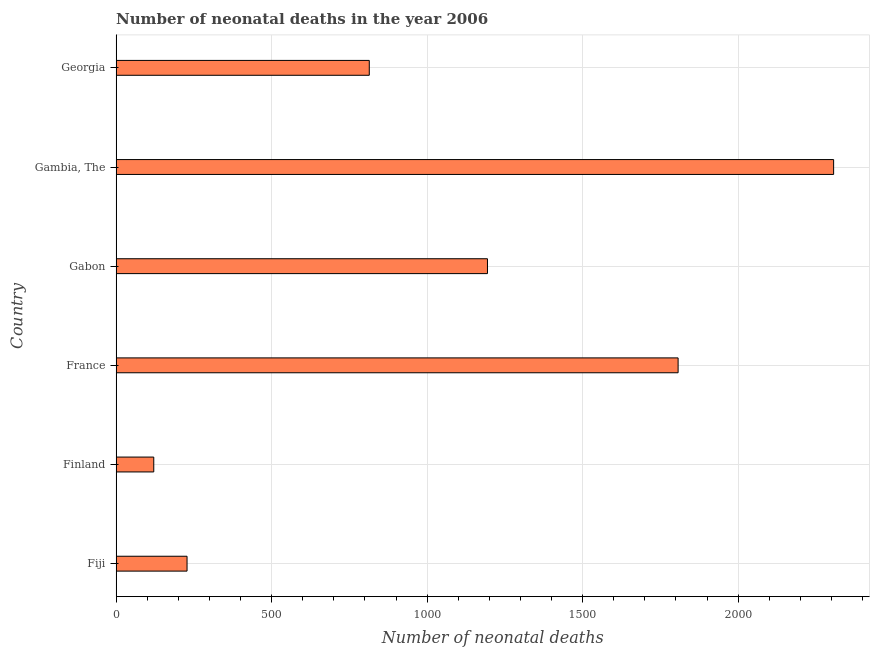What is the title of the graph?
Keep it short and to the point. Number of neonatal deaths in the year 2006. What is the label or title of the X-axis?
Your answer should be compact. Number of neonatal deaths. What is the label or title of the Y-axis?
Your answer should be compact. Country. What is the number of neonatal deaths in Gambia, The?
Provide a short and direct response. 2307. Across all countries, what is the maximum number of neonatal deaths?
Provide a short and direct response. 2307. Across all countries, what is the minimum number of neonatal deaths?
Offer a very short reply. 121. In which country was the number of neonatal deaths maximum?
Make the answer very short. Gambia, The. In which country was the number of neonatal deaths minimum?
Offer a very short reply. Finland. What is the sum of the number of neonatal deaths?
Make the answer very short. 6471. What is the difference between the number of neonatal deaths in France and Georgia?
Your answer should be very brief. 993. What is the average number of neonatal deaths per country?
Give a very brief answer. 1078. What is the median number of neonatal deaths?
Your answer should be very brief. 1004. In how many countries, is the number of neonatal deaths greater than 400 ?
Your answer should be compact. 4. What is the ratio of the number of neonatal deaths in France to that in Gambia, The?
Your response must be concise. 0.78. Is the number of neonatal deaths in Gabon less than that in Georgia?
Keep it short and to the point. No. Is the difference between the number of neonatal deaths in France and Georgia greater than the difference between any two countries?
Your response must be concise. No. What is the difference between the highest and the lowest number of neonatal deaths?
Your response must be concise. 2186. How many bars are there?
Ensure brevity in your answer.  6. How many countries are there in the graph?
Give a very brief answer. 6. Are the values on the major ticks of X-axis written in scientific E-notation?
Provide a succinct answer. No. What is the Number of neonatal deaths in Fiji?
Offer a terse response. 228. What is the Number of neonatal deaths of Finland?
Provide a succinct answer. 121. What is the Number of neonatal deaths in France?
Provide a succinct answer. 1807. What is the Number of neonatal deaths of Gabon?
Make the answer very short. 1194. What is the Number of neonatal deaths of Gambia, The?
Keep it short and to the point. 2307. What is the Number of neonatal deaths in Georgia?
Provide a succinct answer. 814. What is the difference between the Number of neonatal deaths in Fiji and Finland?
Ensure brevity in your answer.  107. What is the difference between the Number of neonatal deaths in Fiji and France?
Your answer should be very brief. -1579. What is the difference between the Number of neonatal deaths in Fiji and Gabon?
Your answer should be very brief. -966. What is the difference between the Number of neonatal deaths in Fiji and Gambia, The?
Ensure brevity in your answer.  -2079. What is the difference between the Number of neonatal deaths in Fiji and Georgia?
Offer a very short reply. -586. What is the difference between the Number of neonatal deaths in Finland and France?
Offer a very short reply. -1686. What is the difference between the Number of neonatal deaths in Finland and Gabon?
Your answer should be very brief. -1073. What is the difference between the Number of neonatal deaths in Finland and Gambia, The?
Offer a very short reply. -2186. What is the difference between the Number of neonatal deaths in Finland and Georgia?
Ensure brevity in your answer.  -693. What is the difference between the Number of neonatal deaths in France and Gabon?
Offer a very short reply. 613. What is the difference between the Number of neonatal deaths in France and Gambia, The?
Provide a succinct answer. -500. What is the difference between the Number of neonatal deaths in France and Georgia?
Your answer should be compact. 993. What is the difference between the Number of neonatal deaths in Gabon and Gambia, The?
Ensure brevity in your answer.  -1113. What is the difference between the Number of neonatal deaths in Gabon and Georgia?
Provide a succinct answer. 380. What is the difference between the Number of neonatal deaths in Gambia, The and Georgia?
Your answer should be compact. 1493. What is the ratio of the Number of neonatal deaths in Fiji to that in Finland?
Provide a short and direct response. 1.88. What is the ratio of the Number of neonatal deaths in Fiji to that in France?
Your answer should be very brief. 0.13. What is the ratio of the Number of neonatal deaths in Fiji to that in Gabon?
Provide a short and direct response. 0.19. What is the ratio of the Number of neonatal deaths in Fiji to that in Gambia, The?
Your answer should be compact. 0.1. What is the ratio of the Number of neonatal deaths in Fiji to that in Georgia?
Provide a succinct answer. 0.28. What is the ratio of the Number of neonatal deaths in Finland to that in France?
Your answer should be compact. 0.07. What is the ratio of the Number of neonatal deaths in Finland to that in Gabon?
Give a very brief answer. 0.1. What is the ratio of the Number of neonatal deaths in Finland to that in Gambia, The?
Provide a succinct answer. 0.05. What is the ratio of the Number of neonatal deaths in Finland to that in Georgia?
Keep it short and to the point. 0.15. What is the ratio of the Number of neonatal deaths in France to that in Gabon?
Your answer should be compact. 1.51. What is the ratio of the Number of neonatal deaths in France to that in Gambia, The?
Provide a succinct answer. 0.78. What is the ratio of the Number of neonatal deaths in France to that in Georgia?
Offer a very short reply. 2.22. What is the ratio of the Number of neonatal deaths in Gabon to that in Gambia, The?
Make the answer very short. 0.52. What is the ratio of the Number of neonatal deaths in Gabon to that in Georgia?
Keep it short and to the point. 1.47. What is the ratio of the Number of neonatal deaths in Gambia, The to that in Georgia?
Give a very brief answer. 2.83. 